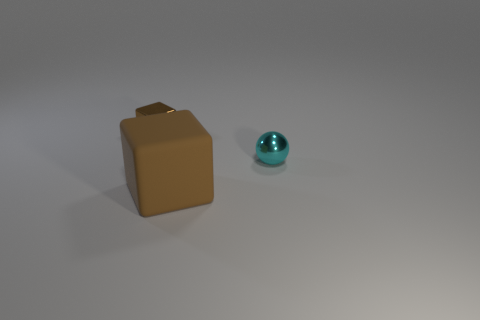Are there more big brown matte blocks that are in front of the tiny cube than large things?
Give a very brief answer. No. There is a cyan shiny object; is its shape the same as the shiny object that is on the left side of the small metal ball?
Provide a succinct answer. No. There is a metallic thing that is the same color as the rubber thing; what shape is it?
Provide a succinct answer. Cube. There is a metal object to the left of the brown cube on the right side of the tiny metal cube; how many tiny objects are behind it?
Your answer should be very brief. 0. What color is the metallic object that is the same size as the sphere?
Your response must be concise. Brown. What is the size of the brown cube in front of the brown cube behind the cyan thing?
Make the answer very short. Large. What is the size of the other object that is the same color as the big object?
Keep it short and to the point. Small. How many other things are the same size as the cyan thing?
Your answer should be compact. 1. What number of small gray blocks are there?
Offer a very short reply. 0. Is the size of the shiny ball the same as the brown rubber thing?
Provide a short and direct response. No. 